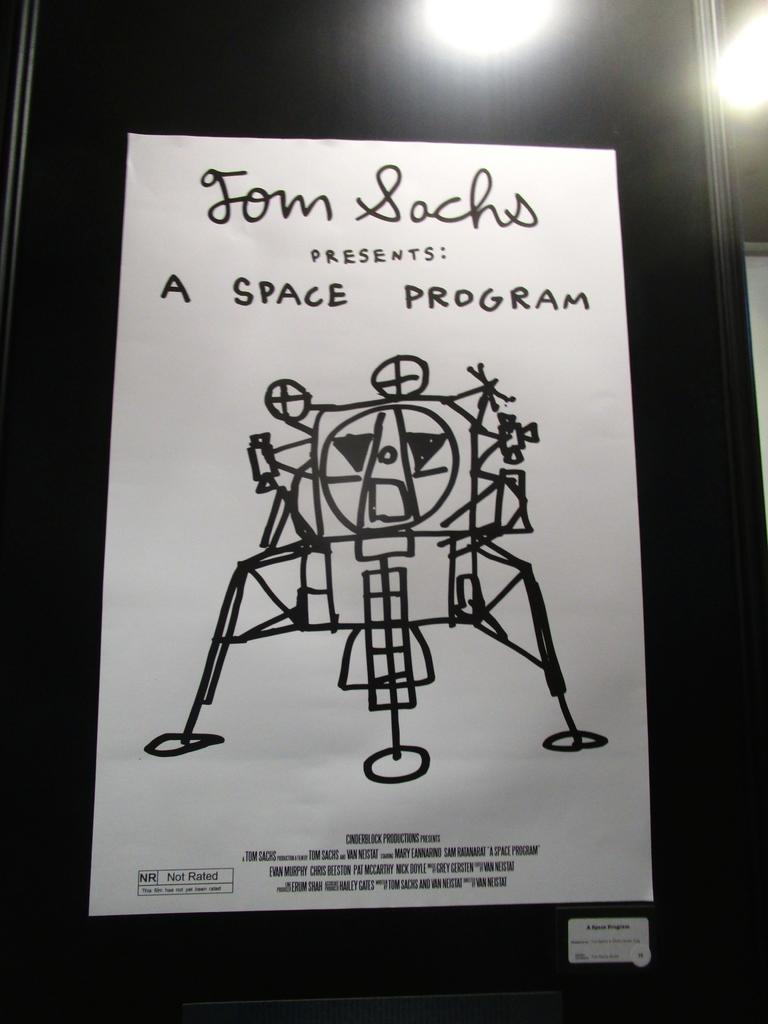Provide a one-sentence caption for the provided image. A black and white movie poster with a hand drawn spaceship. It says "Tom Sachs presents: A Space Program.". 